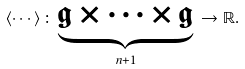Convert formula to latex. <formula><loc_0><loc_0><loc_500><loc_500>\left \langle \cdots \right \rangle \colon \, \underset { n + 1 } { \underbrace { \mathfrak { g } \times \cdots \times \mathfrak { g } } } \, \rightarrow \mathbb { R } .</formula> 